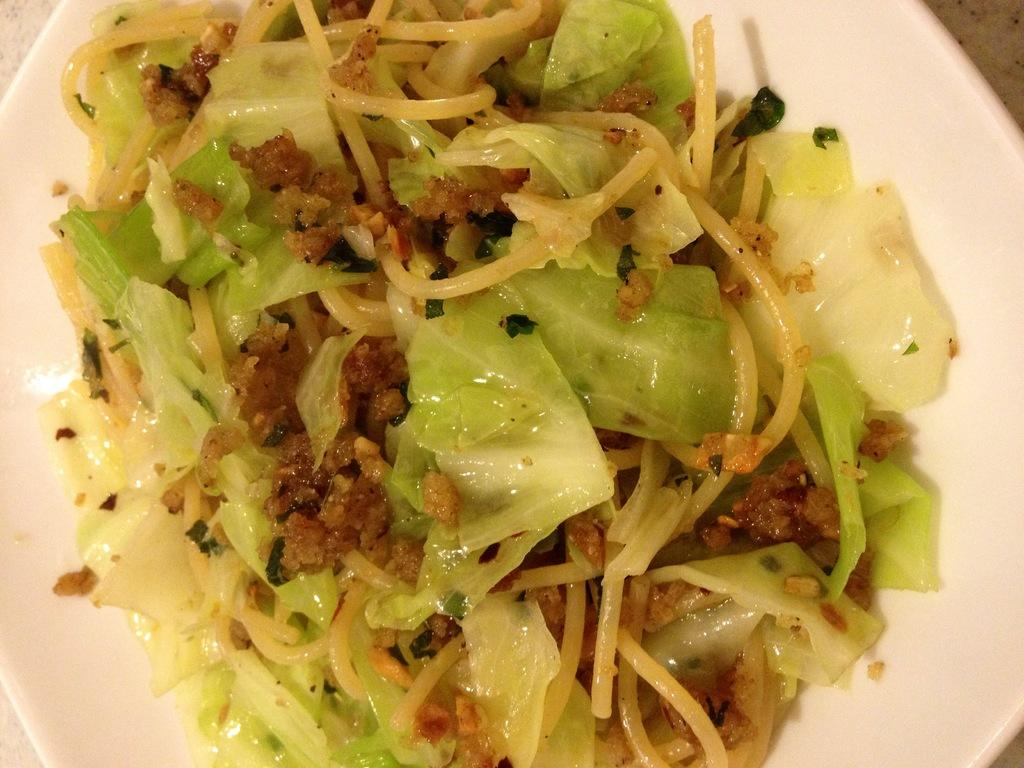What is the main subject of the image? The main subject of the image is a food item on a white plate. Can you describe the colors of the food item? The food has green, brown, and cream colors. What type of soda is being poured into the middle of the plate in the image? There is no soda present in the image; it features a food item on a white plate with green, brown, and cream colors. 